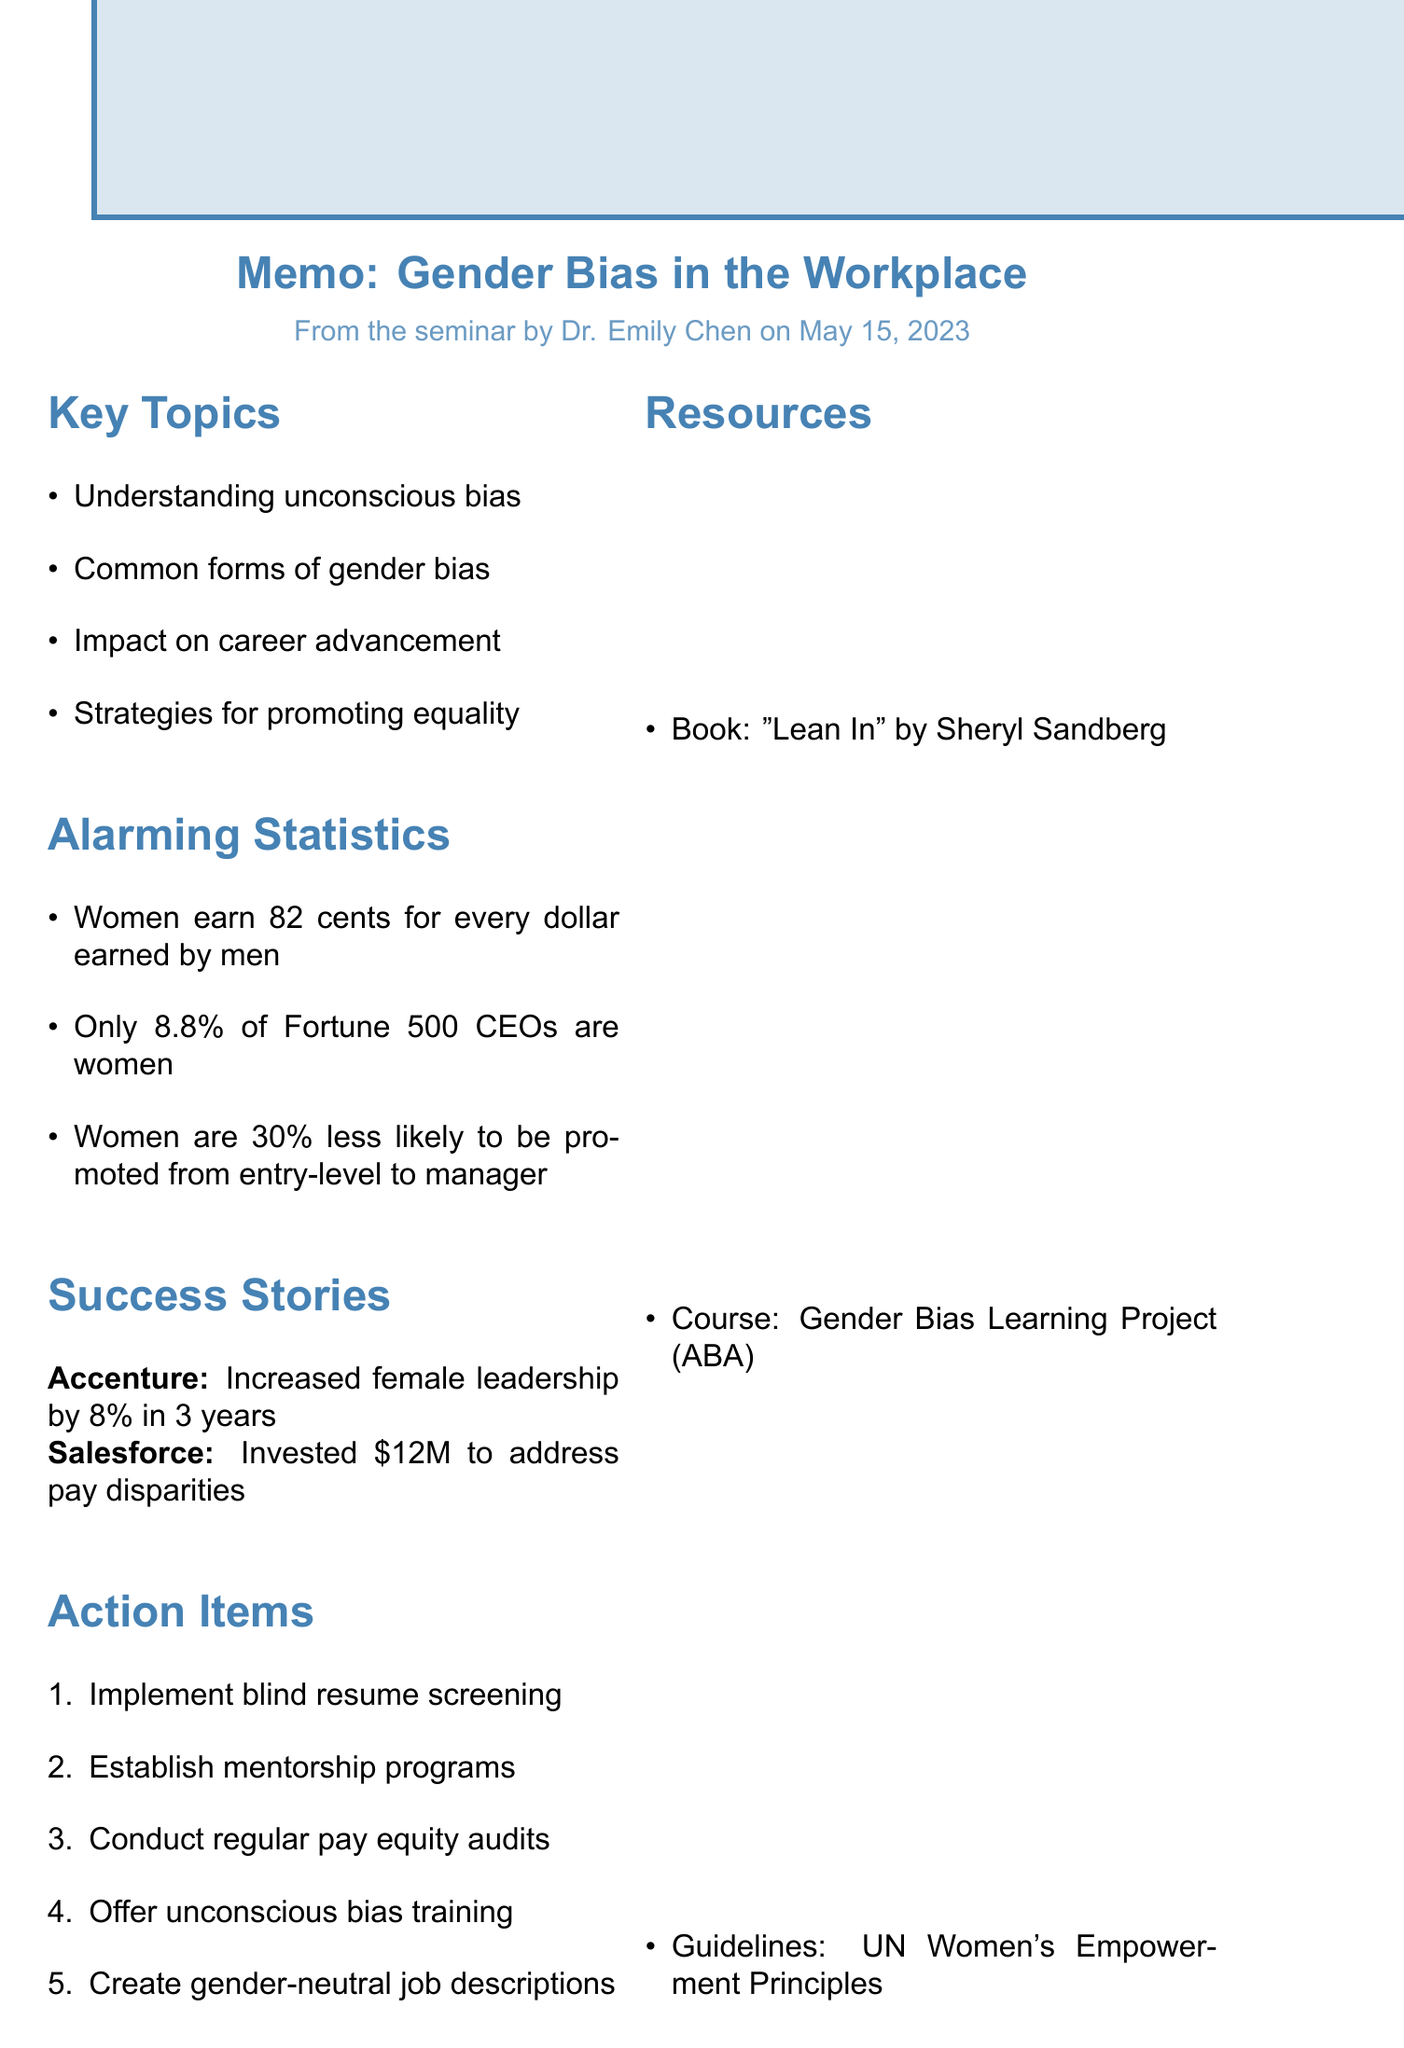What is the title of the seminar? The title of the seminar is provided at the beginning of the document.
Answer: Recognizing and Addressing Gender Bias in the Workplace Who was the presenter of the seminar? The presenter's name is listed within the seminar details section.
Answer: Dr. Emily Chen What date was the seminar held? The date of the seminar is mentioned next to the seminar title.
Answer: May 15, 2023 What percentage of Fortune 500 CEOs are women? This statistic is included under the section about alarming statistics in the document.
Answer: 8.8% What initiative did Accenture implement? The initiative taken by Accenture is noted in the case studies section.
Answer: 50/50 gender balance by 2025 How much money did Salesforce invest to address pay disparities? This amount is stated in the case studies section regarding Salesforce's actions.
Answer: $12 million What is one action item suggested to reduce hiring bias? The action items are listed in bullet points, outlining steps to take against bias.
Answer: Implement blind resume screening What type of resource is "Lean In: Women, Work, and the Will to Lead"? This is categorized under the resources section of the memo.
Answer: Book What personal value is emphasized in the personal reflection section? This value is highlighted in the personal reflection of the memo regarding workplace issues.
Answer: Equality and respect 